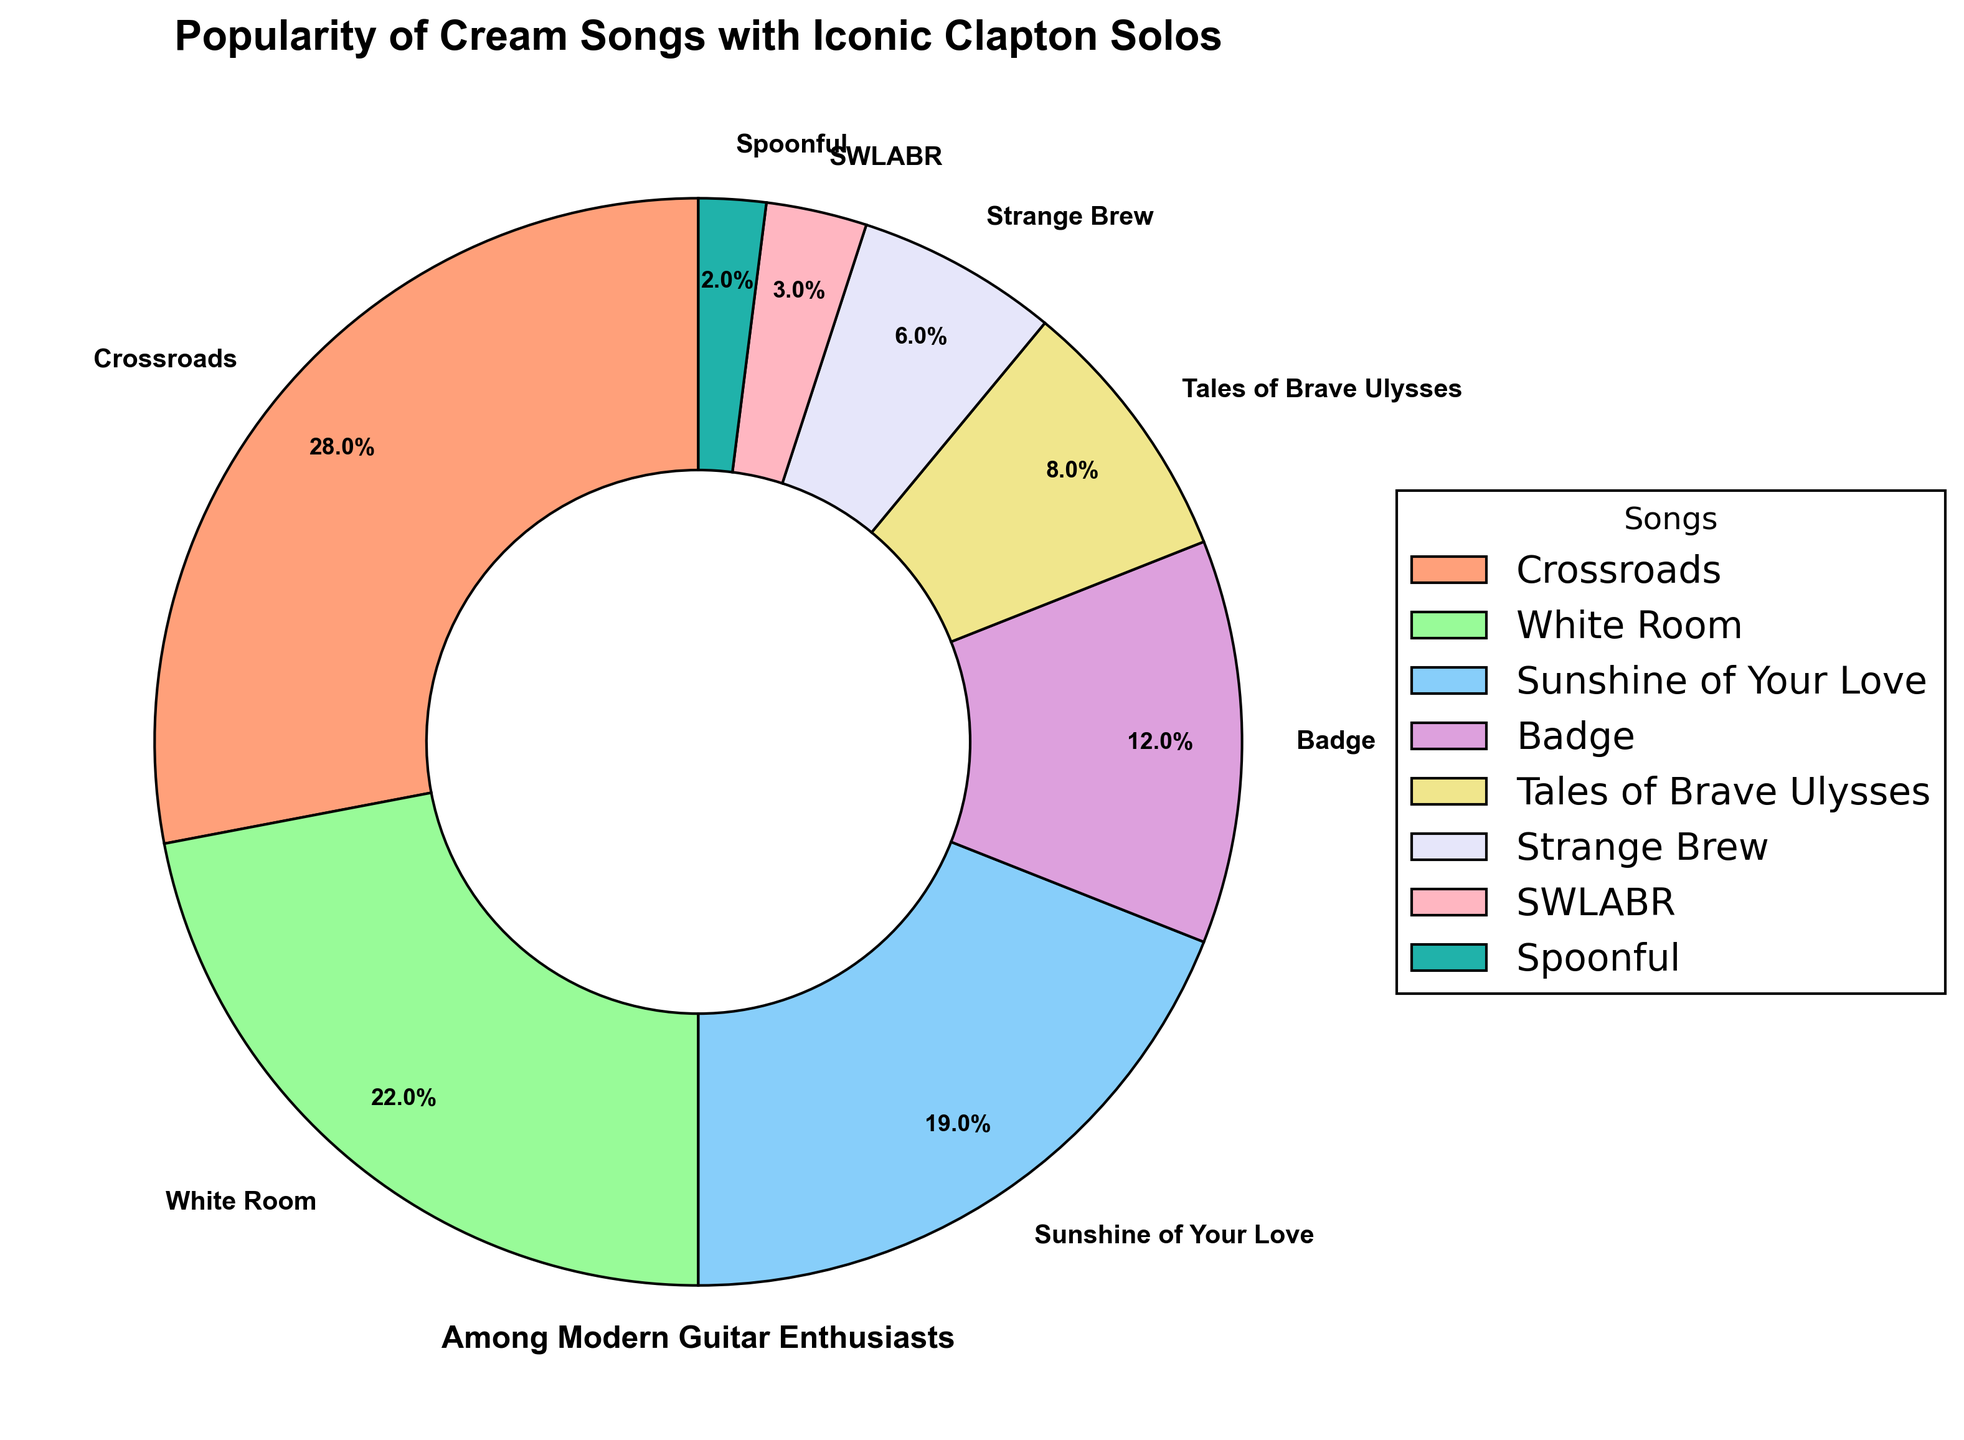Which song has the highest popularity among modern guitar enthusiasts? By looking at the pie chart, the segment for "Crossroads" is the largest, indicating it has the highest percentage.
Answer: Crossroads What is the total popularity percentage for "White Room" and "Sunshine of Your Love"? The percentages for "White Room" and "Sunshine of Your Love" are 22% and 19% respectively. Adding them gives 22 + 19 = 41%.
Answer: 41% Which songs have a popularity percentage less than 10%? From the pie chart, "Tales of Brave Ulysses" (8%), "Strange Brew" (6%), "SWLABR" (3%), and "Spoonful" (2%) have percentages less than 10%.
Answer: Tales of Brave Ulysses, Strange Brew, SWLABR, Spoonful How does the popularity of "Badge" compare to that of "Sunshine of Your Love"? "Badge" has a popularity of 12%, while "Sunshine of Your Love" has 19%. So, "Badge" has a lower popularity than "Sunshine of Your Love".
Answer: Lower What is the combined popularity percentage of the least popular three songs? The least popular three songs are "Spoonful" (2%), "SWLABR" (3%), and "Strange Brew" (6%). Adding them gives 2 + 3 + 6 = 11%.
Answer: 11% How does the popularity of "White Room" compare to "Badge"? "White Room" has a popularity of 22% while "Badge" has 12%. Thus, "White Room" is more popular than "Badge".
Answer: More popular If you combine the popularity percentages of "Crossroads" and "Badge", what fraction of the total does this combined percentage represent? "Crossroads" has 28%, and "Badge" has 12%. The combined total is 28 + 12 = 40%. The entire chart represents 100%, so the fraction is 40/100 = 0.4 or 40%.
Answer: 0.4 or 40% Which song has double-digit popularity but didn't make the top three? The top three are "Crossroads" (28%), "White Room" (22%), and "Sunshine of Your Love" (19%). The only other song with double-digit popularity is "Badge" (12%).
Answer: Badge What is the color of the segment representing "Sunshine of Your Love"? Looking at the pie chart, "Sunshine of Your Love" is the third largest segment, which is represented by blue.
Answer: Blue 